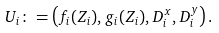<formula> <loc_0><loc_0><loc_500><loc_500>U _ { i } \colon = \left ( f _ { i } ( Z _ { i } ) , g _ { i } ( Z _ { i } ) , D ^ { x } _ { i } , D ^ { y } _ { i } \right ) .</formula> 